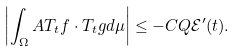Convert formula to latex. <formula><loc_0><loc_0><loc_500><loc_500>\left | \int _ { \Omega } A T _ { t } f \cdot T _ { t } g d \mu \right | \leq - C Q \mathcal { E } ^ { \prime } ( t ) .</formula> 